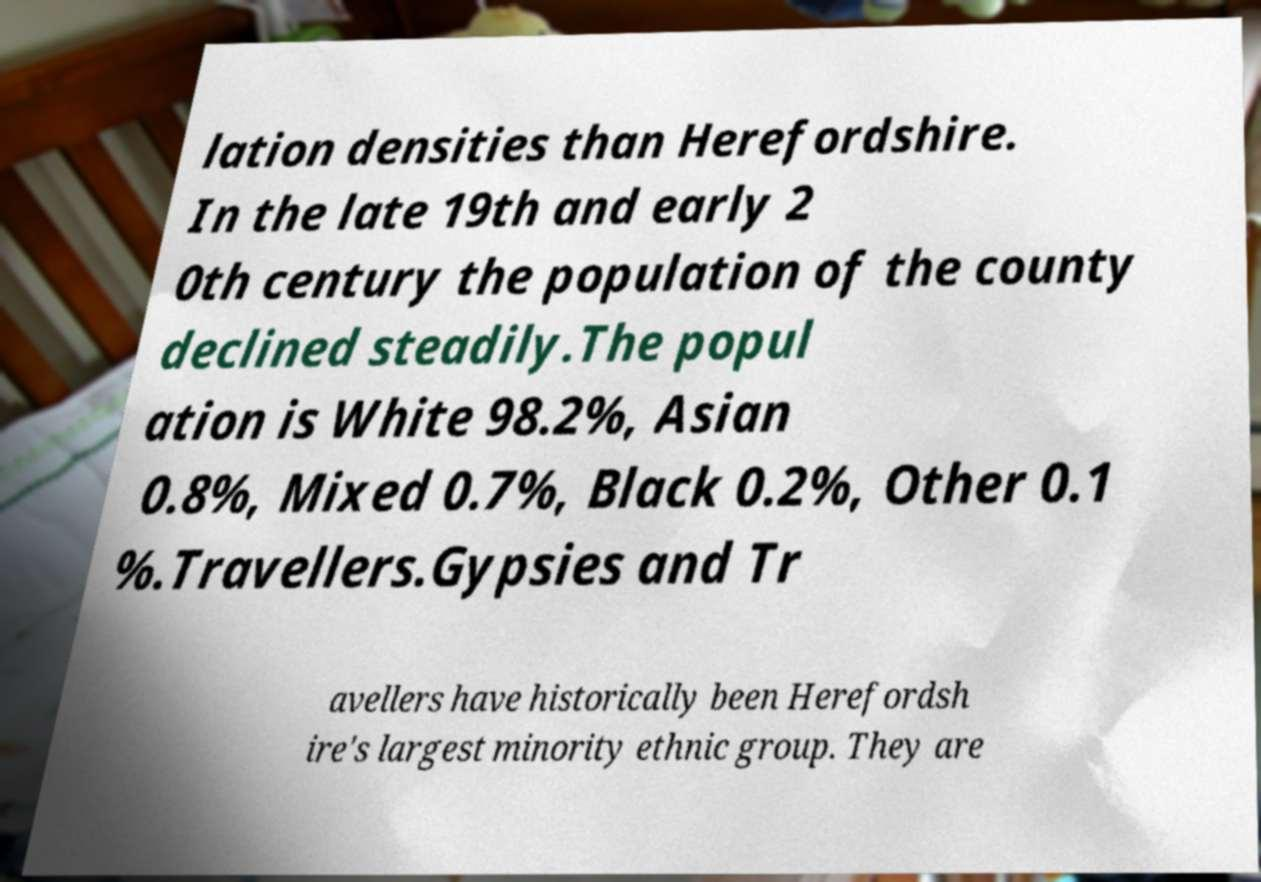For documentation purposes, I need the text within this image transcribed. Could you provide that? lation densities than Herefordshire. In the late 19th and early 2 0th century the population of the county declined steadily.The popul ation is White 98.2%, Asian 0.8%, Mixed 0.7%, Black 0.2%, Other 0.1 %.Travellers.Gypsies and Tr avellers have historically been Herefordsh ire's largest minority ethnic group. They are 